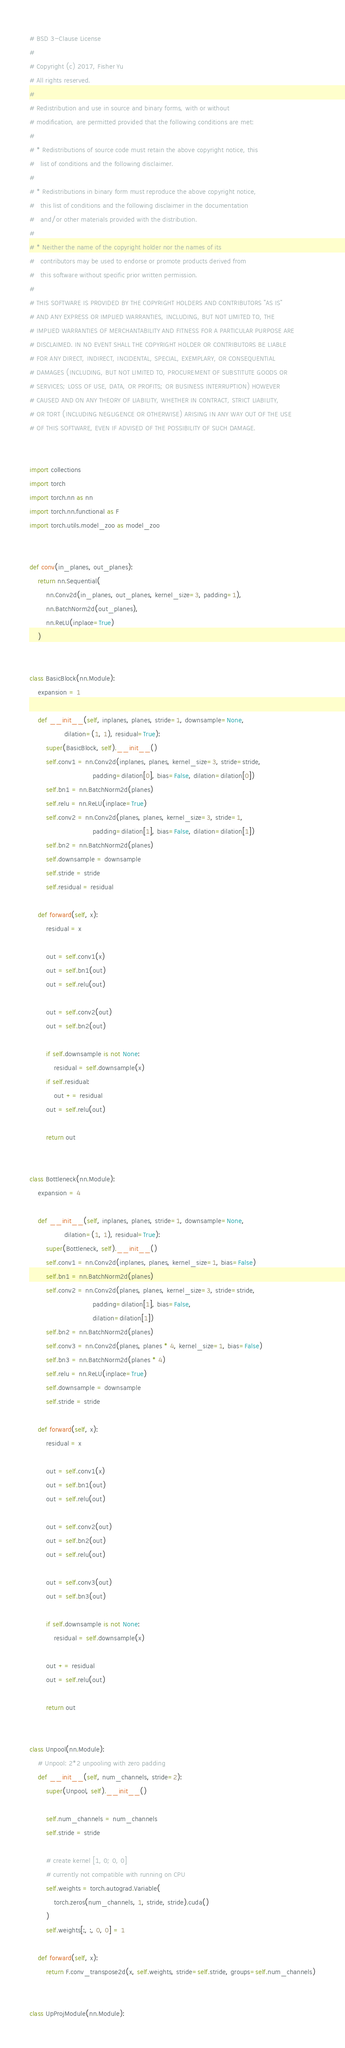Convert code to text. <code><loc_0><loc_0><loc_500><loc_500><_Python_># BSD 3-Clause License
#
# Copyright (c) 2017, Fisher Yu
# All rights reserved.
#
# Redistribution and use in source and binary forms, with or without
# modification, are permitted provided that the following conditions are met:
#
# * Redistributions of source code must retain the above copyright notice, this
#   list of conditions and the following disclaimer.
#
# * Redistributions in binary form must reproduce the above copyright notice,
#   this list of conditions and the following disclaimer in the documentation
#   and/or other materials provided with the distribution.
#
# * Neither the name of the copyright holder nor the names of its
#   contributors may be used to endorse or promote products derived from
#   this software without specific prior written permission.
#
# THIS SOFTWARE IS PROVIDED BY THE COPYRIGHT HOLDERS AND CONTRIBUTORS "AS IS"
# AND ANY EXPRESS OR IMPLIED WARRANTIES, INCLUDING, BUT NOT LIMITED TO, THE
# IMPLIED WARRANTIES OF MERCHANTABILITY AND FITNESS FOR A PARTICULAR PURPOSE ARE
# DISCLAIMED. IN NO EVENT SHALL THE COPYRIGHT HOLDER OR CONTRIBUTORS BE LIABLE
# FOR ANY DIRECT, INDIRECT, INCIDENTAL, SPECIAL, EXEMPLARY, OR CONSEQUENTIAL
# DAMAGES (INCLUDING, BUT NOT LIMITED TO, PROCUREMENT OF SUBSTITUTE GOODS OR
# SERVICES; LOSS OF USE, DATA, OR PROFITS; OR BUSINESS INTERRUPTION) HOWEVER
# CAUSED AND ON ANY THEORY OF LIABILITY, WHETHER IN CONTRACT, STRICT LIABILITY,
# OR TORT (INCLUDING NEGLIGENCE OR OTHERWISE) ARISING IN ANY WAY OUT OF THE USE
# OF THIS SOFTWARE, EVEN IF ADVISED OF THE POSSIBILITY OF SUCH DAMAGE.


import collections
import torch
import torch.nn as nn
import torch.nn.functional as F
import torch.utils.model_zoo as model_zoo


def conv(in_planes, out_planes):
    return nn.Sequential(
        nn.Conv2d(in_planes, out_planes, kernel_size=3, padding=1),
        nn.BatchNorm2d(out_planes),
        nn.ReLU(inplace=True)
    )


class BasicBlock(nn.Module):
    expansion = 1

    def __init__(self, inplanes, planes, stride=1, downsample=None,
                 dilation=(1, 1), residual=True):
        super(BasicBlock, self).__init__()
        self.conv1 = nn.Conv2d(inplanes, planes, kernel_size=3, stride=stride,
                               padding=dilation[0], bias=False, dilation=dilation[0])
        self.bn1 = nn.BatchNorm2d(planes)
        self.relu = nn.ReLU(inplace=True)
        self.conv2 = nn.Conv2d(planes, planes, kernel_size=3, stride=1,
                               padding=dilation[1], bias=False, dilation=dilation[1])
        self.bn2 = nn.BatchNorm2d(planes)
        self.downsample = downsample
        self.stride = stride
        self.residual = residual

    def forward(self, x):
        residual = x

        out = self.conv1(x)
        out = self.bn1(out)
        out = self.relu(out)

        out = self.conv2(out)
        out = self.bn2(out)

        if self.downsample is not None:
            residual = self.downsample(x)
        if self.residual:
            out += residual
        out = self.relu(out)

        return out


class Bottleneck(nn.Module):
    expansion = 4

    def __init__(self, inplanes, planes, stride=1, downsample=None,
                 dilation=(1, 1), residual=True):
        super(Bottleneck, self).__init__()
        self.conv1 = nn.Conv2d(inplanes, planes, kernel_size=1, bias=False)
        self.bn1 = nn.BatchNorm2d(planes)
        self.conv2 = nn.Conv2d(planes, planes, kernel_size=3, stride=stride,
                               padding=dilation[1], bias=False,
                               dilation=dilation[1])
        self.bn2 = nn.BatchNorm2d(planes)
        self.conv3 = nn.Conv2d(planes, planes * 4, kernel_size=1, bias=False)
        self.bn3 = nn.BatchNorm2d(planes * 4)
        self.relu = nn.ReLU(inplace=True)
        self.downsample = downsample
        self.stride = stride

    def forward(self, x):
        residual = x

        out = self.conv1(x)
        out = self.bn1(out)
        out = self.relu(out)

        out = self.conv2(out)
        out = self.bn2(out)
        out = self.relu(out)

        out = self.conv3(out)
        out = self.bn3(out)

        if self.downsample is not None:
            residual = self.downsample(x)

        out += residual
        out = self.relu(out)

        return out


class Unpool(nn.Module):
    # Unpool: 2*2 unpooling with zero padding
    def __init__(self, num_channels, stride=2):
        super(Unpool, self).__init__()

        self.num_channels = num_channels
        self.stride = stride

        # create kernel [1, 0; 0, 0]
        # currently not compatible with running on CPU
        self.weights = torch.autograd.Variable(
            torch.zeros(num_channels, 1, stride, stride).cuda()
        )
        self.weights[:, :, 0, 0] = 1

    def forward(self, x):
        return F.conv_transpose2d(x, self.weights, stride=self.stride, groups=self.num_channels)


class UpProjModule(nn.Module):</code> 